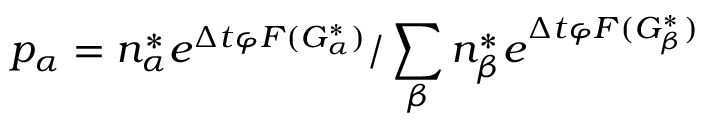Convert formula to latex. <formula><loc_0><loc_0><loc_500><loc_500>p _ { \alpha } = n _ { \alpha } ^ { * } e ^ { \Delta t \varphi F ( G _ { \alpha } ^ { * } ) } / \sum _ { \beta } n _ { \beta } ^ { * } e ^ { \Delta t \varphi F ( G _ { \beta } ^ { * } ) }</formula> 